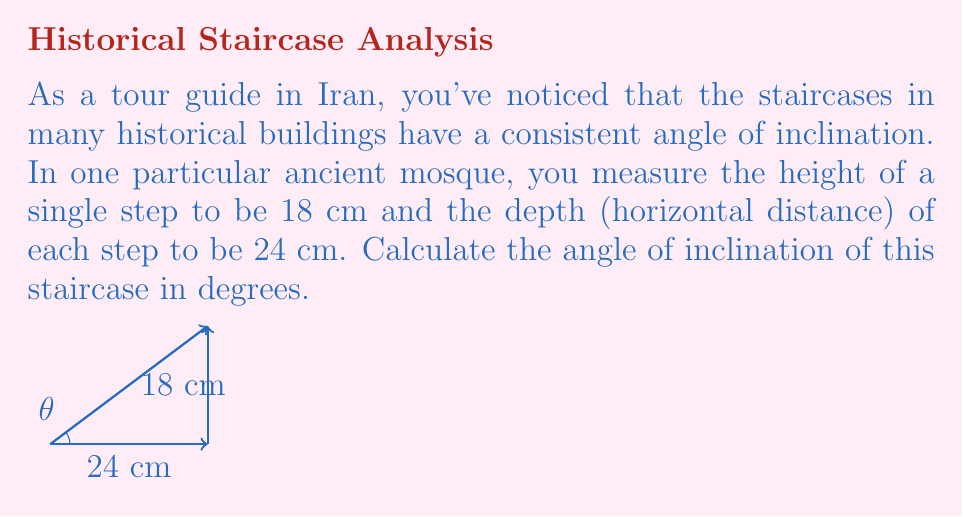Solve this math problem. To find the angle of inclination, we need to use trigonometry. The staircase forms a right triangle, where:

1. The opposite side is the height of the step (18 cm)
2. The adjacent side is the depth of the step (24 cm)
3. The hypotenuse is the sloping edge of the staircase

We can use the tangent function to calculate the angle:

$$\tan(\theta) = \frac{\text{opposite}}{\text{adjacent}} = \frac{\text{height}}{\text{depth}}$$

Substituting our values:

$$\tan(\theta) = \frac{18}{24} = \frac{3}{4} = 0.75$$

To find the angle $\theta$, we need to use the inverse tangent (arctangent) function:

$$\theta = \arctan(0.75)$$

Using a calculator or computer:

$$\theta \approx 36.87^\circ$$

Rounding to two decimal places:

$$\theta \approx 36.87^\circ$$
Answer: $36.87^\circ$ 